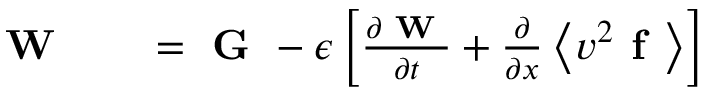Convert formula to latex. <formula><loc_0><loc_0><loc_500><loc_500>\begin{array} { r l r } { W } & { = G - \epsilon \left [ \frac { \partial W } { \partial t } + \frac { \partial } { \partial x } \left \langle v ^ { 2 } f \right \rangle \right ] } \end{array}</formula> 